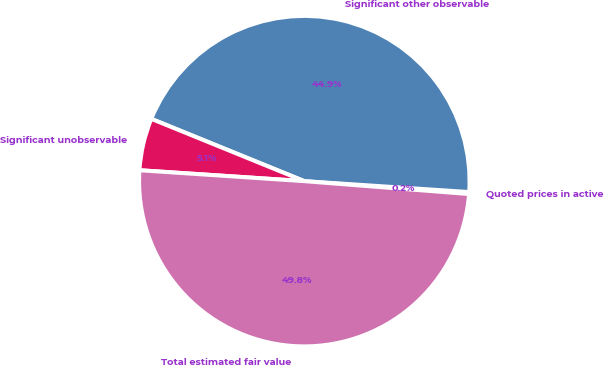Convert chart. <chart><loc_0><loc_0><loc_500><loc_500><pie_chart><fcel>Quoted prices in active<fcel>Significant other observable<fcel>Significant unobservable<fcel>Total estimated fair value<nl><fcel>0.19%<fcel>44.9%<fcel>5.1%<fcel>49.81%<nl></chart> 